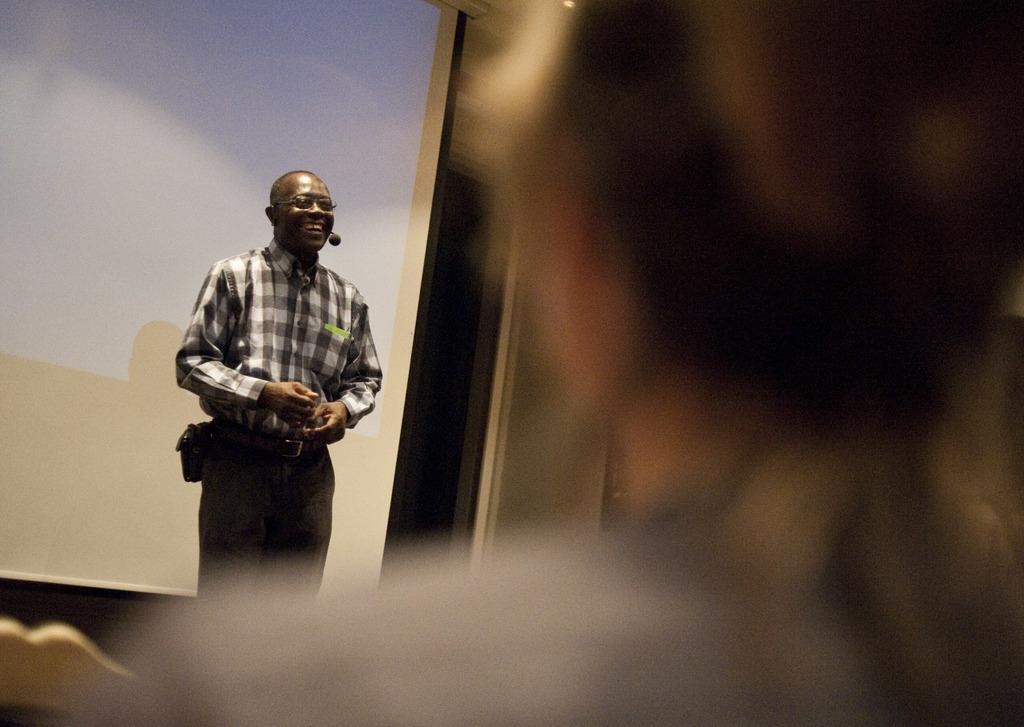Please provide a concise description of this image. In this picture, we can see a man is standing on the floor and explaining something and behind the man there is a projector screen and in front of the man there is another person. 